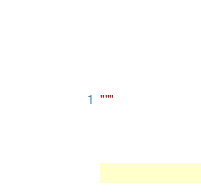<code> <loc_0><loc_0><loc_500><loc_500><_Python_>"""
</code> 